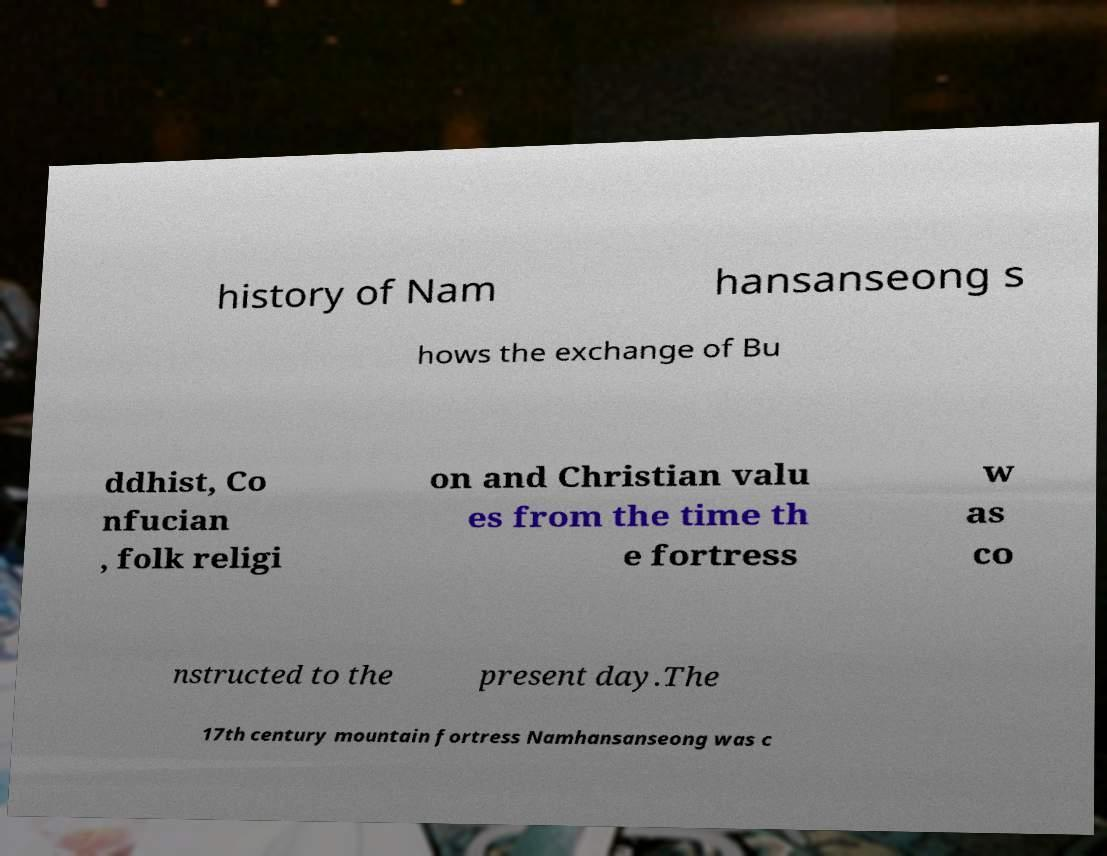I need the written content from this picture converted into text. Can you do that? history of Nam hansanseong s hows the exchange of Bu ddhist, Co nfucian , folk religi on and Christian valu es from the time th e fortress w as co nstructed to the present day.The 17th century mountain fortress Namhansanseong was c 